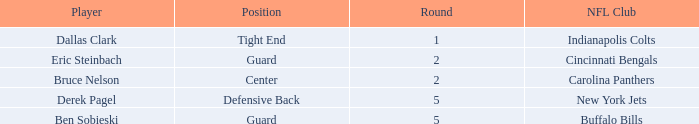Write the full table. {'header': ['Player', 'Position', 'Round', 'NFL Club'], 'rows': [['Dallas Clark', 'Tight End', '1', 'Indianapolis Colts'], ['Eric Steinbach', 'Guard', '2', 'Cincinnati Bengals'], ['Bruce Nelson', 'Center', '2', 'Carolina Panthers'], ['Derek Pagel', 'Defensive Back', '5', 'New York Jets'], ['Ben Sobieski', 'Guard', '5', 'Buffalo Bills']]} What was the last round where derek pagel was drafted with a pick exceeding 50? 5.0. 